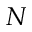Convert formula to latex. <formula><loc_0><loc_0><loc_500><loc_500>N</formula> 